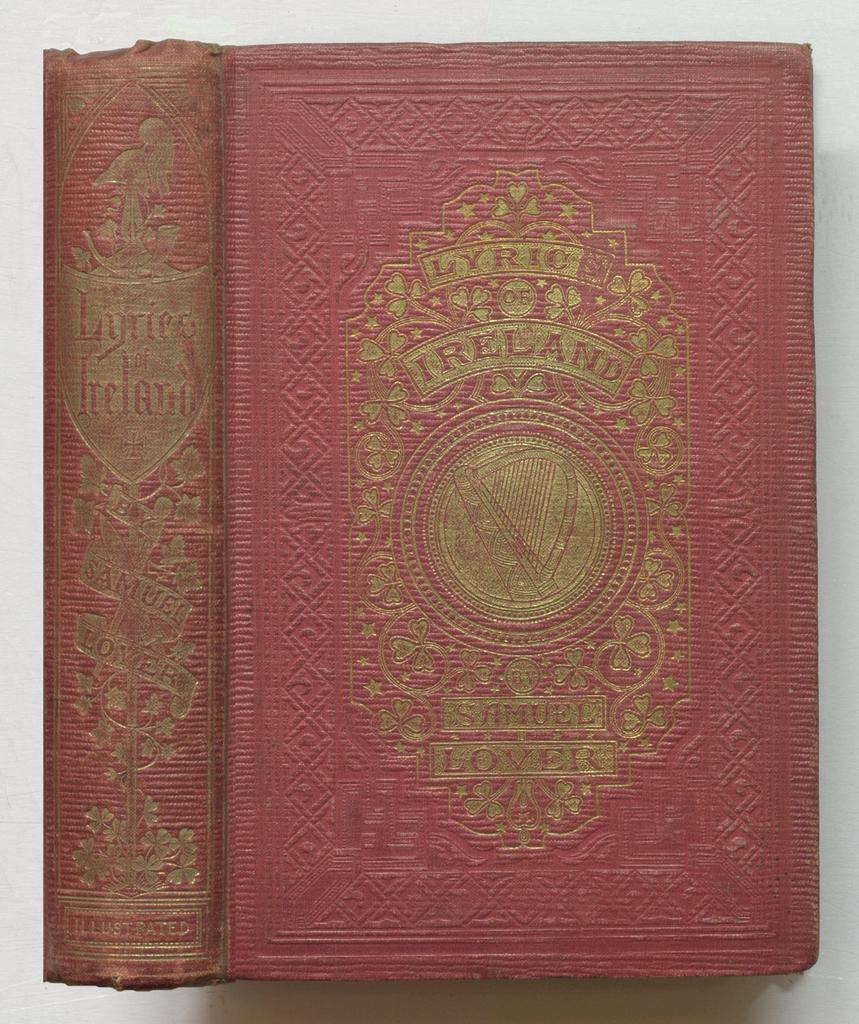<image>
Create a compact narrative representing the image presented. An old red book with Lyrics of Ireland on it. 